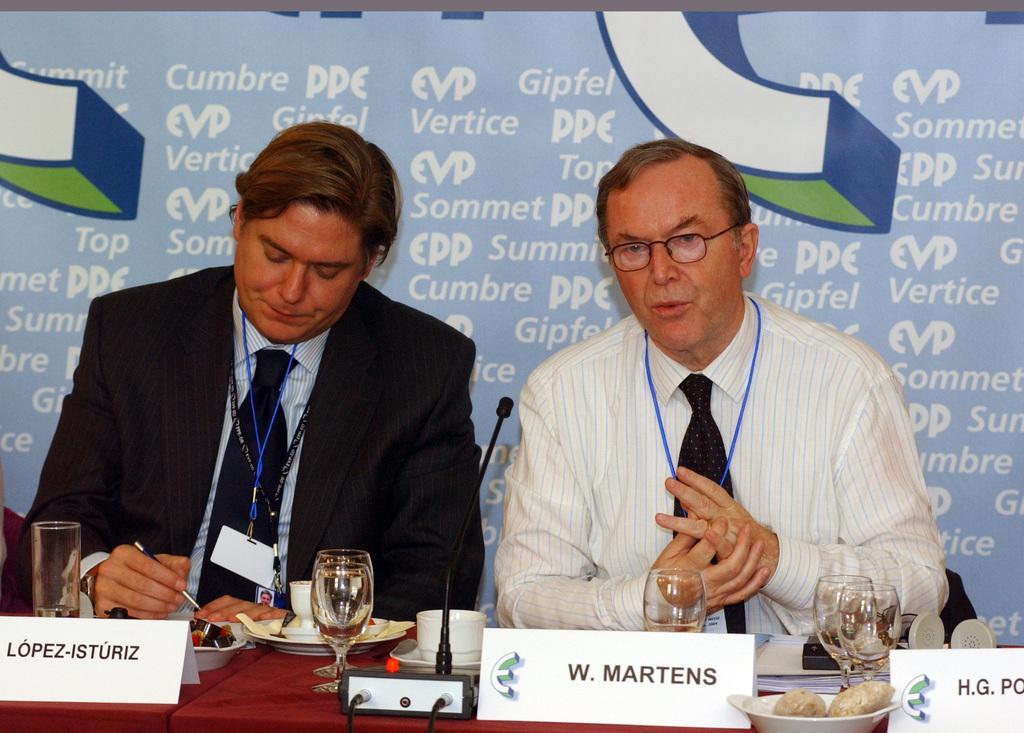Could you give a brief overview of what you see in this image? In this image I can see two people sitting and name plates before them. I can see some glasses, a cup, and other objects on the table. I can see a banner behind them with some text. 